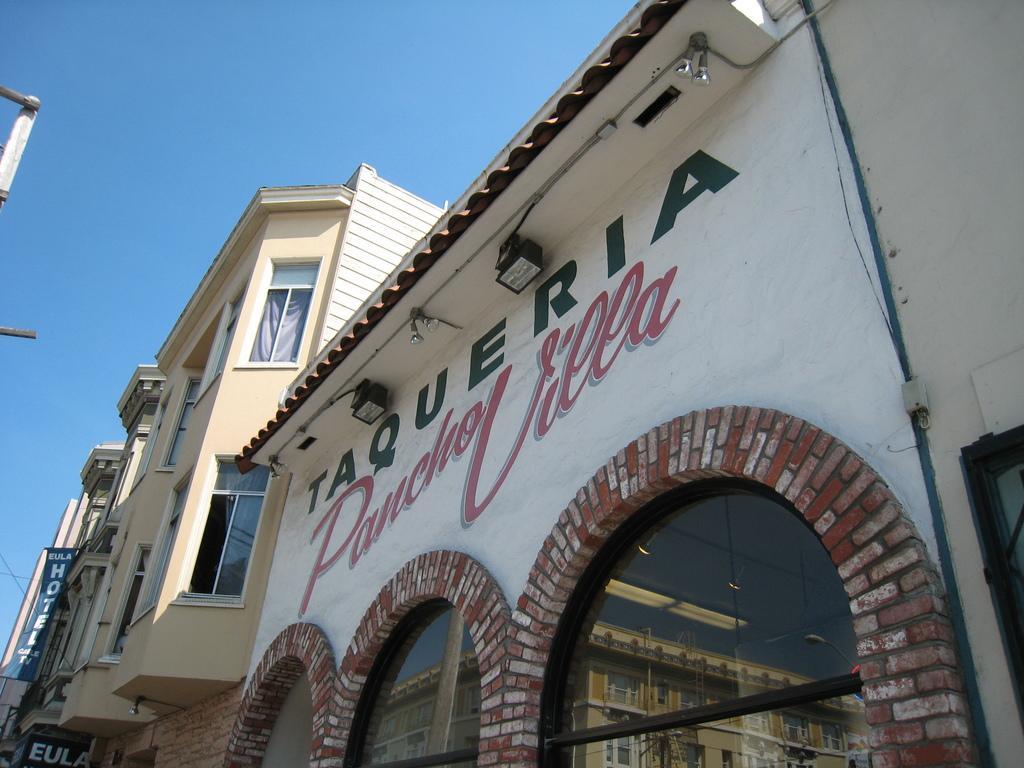How would you summarize this image in a sentence or two? In this picture I can see there are a few buildings and they have glass windows. They have name plates and the sky is clear. 